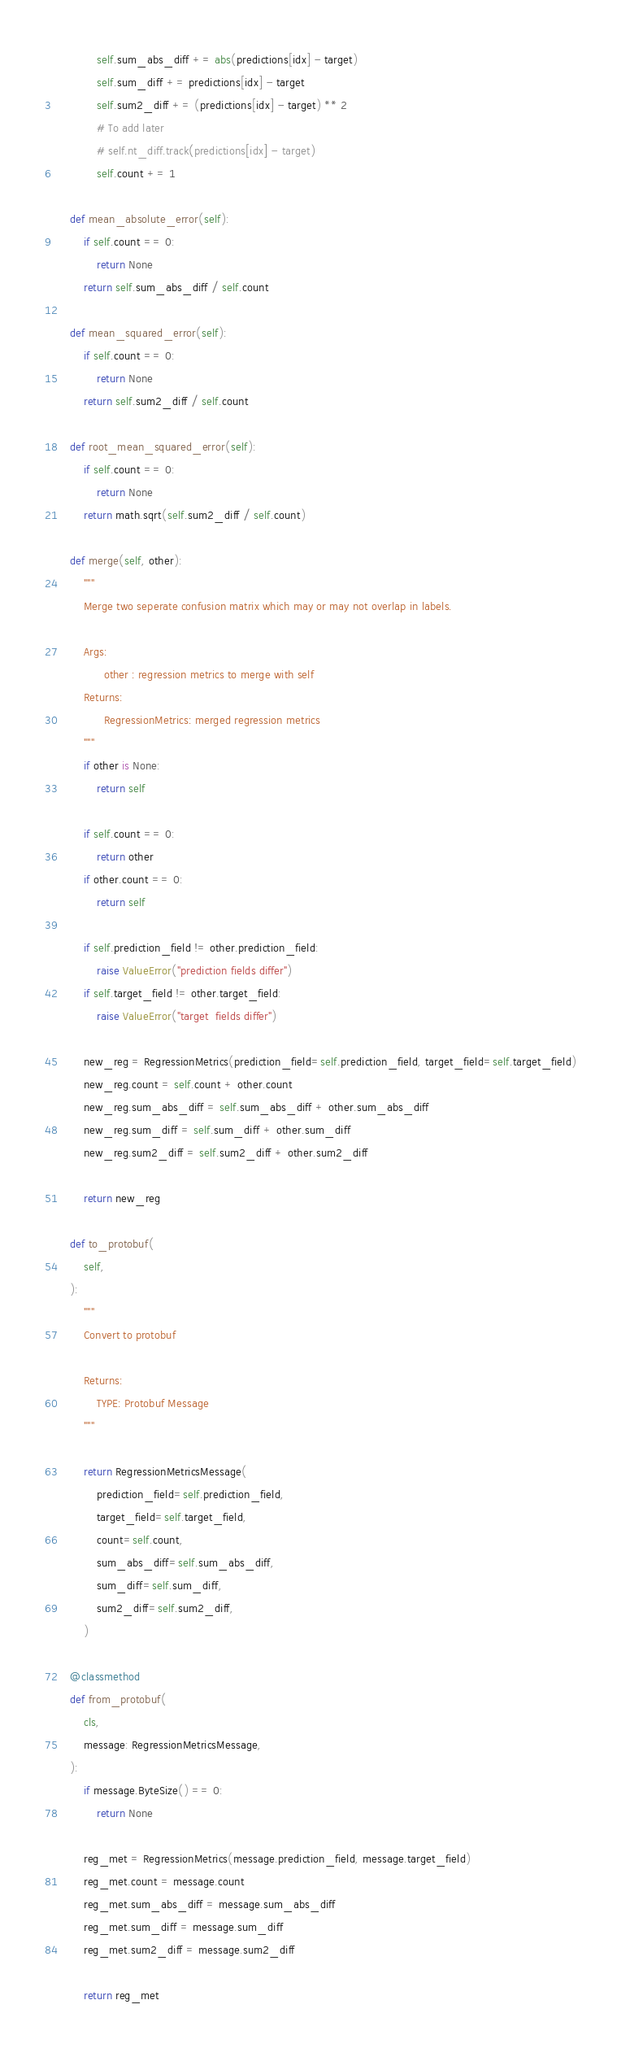<code> <loc_0><loc_0><loc_500><loc_500><_Python_>
            self.sum_abs_diff += abs(predictions[idx] - target)
            self.sum_diff += predictions[idx] - target
            self.sum2_diff += (predictions[idx] - target) ** 2
            # To add later
            # self.nt_diff.track(predictions[idx] - target)
            self.count += 1

    def mean_absolute_error(self):
        if self.count == 0:
            return None
        return self.sum_abs_diff / self.count

    def mean_squared_error(self):
        if self.count == 0:
            return None
        return self.sum2_diff / self.count

    def root_mean_squared_error(self):
        if self.count == 0:
            return None
        return math.sqrt(self.sum2_diff / self.count)

    def merge(self, other):
        """
        Merge two seperate confusion matrix which may or may not overlap in labels.

        Args:
              other : regression metrics to merge with self
        Returns:
              RegressionMetrics: merged regression metrics
        """
        if other is None:
            return self

        if self.count == 0:
            return other
        if other.count == 0:
            return self

        if self.prediction_field != other.prediction_field:
            raise ValueError("prediction fields differ")
        if self.target_field != other.target_field:
            raise ValueError("target  fields differ")

        new_reg = RegressionMetrics(prediction_field=self.prediction_field, target_field=self.target_field)
        new_reg.count = self.count + other.count
        new_reg.sum_abs_diff = self.sum_abs_diff + other.sum_abs_diff
        new_reg.sum_diff = self.sum_diff + other.sum_diff
        new_reg.sum2_diff = self.sum2_diff + other.sum2_diff

        return new_reg

    def to_protobuf(
        self,
    ):
        """
        Convert to protobuf

        Returns:
            TYPE: Protobuf Message
        """

        return RegressionMetricsMessage(
            prediction_field=self.prediction_field,
            target_field=self.target_field,
            count=self.count,
            sum_abs_diff=self.sum_abs_diff,
            sum_diff=self.sum_diff,
            sum2_diff=self.sum2_diff,
        )

    @classmethod
    def from_protobuf(
        cls,
        message: RegressionMetricsMessage,
    ):
        if message.ByteSize() == 0:
            return None

        reg_met = RegressionMetrics(message.prediction_field, message.target_field)
        reg_met.count = message.count
        reg_met.sum_abs_diff = message.sum_abs_diff
        reg_met.sum_diff = message.sum_diff
        reg_met.sum2_diff = message.sum2_diff

        return reg_met
</code> 